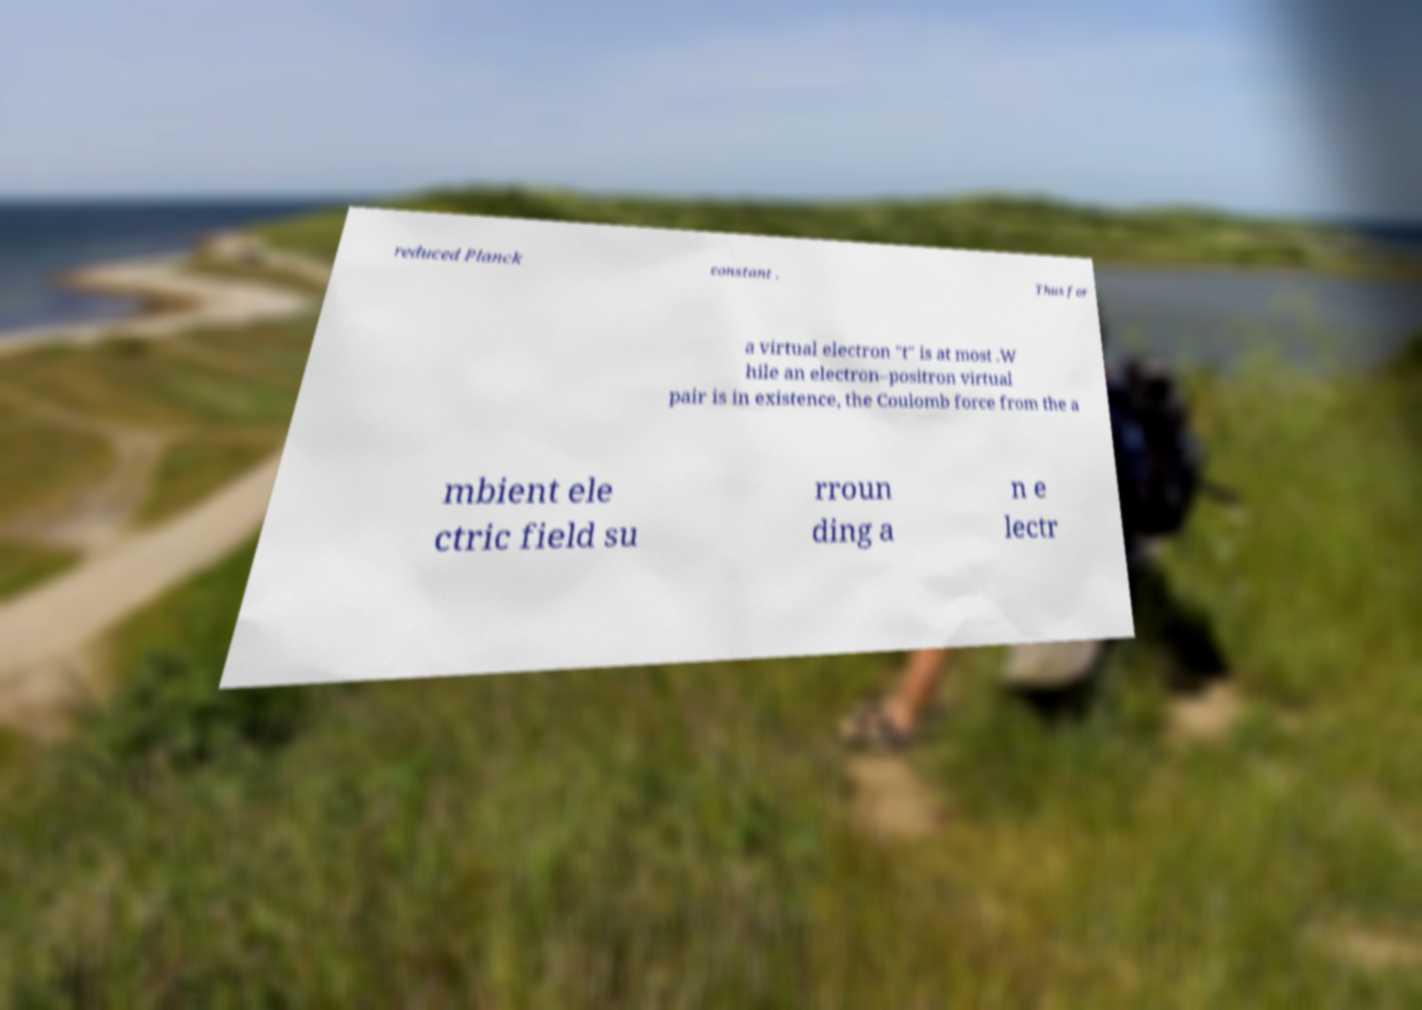Could you extract and type out the text from this image? reduced Planck constant . Thus for a virtual electron "t" is at most .W hile an electron–positron virtual pair is in existence, the Coulomb force from the a mbient ele ctric field su rroun ding a n e lectr 